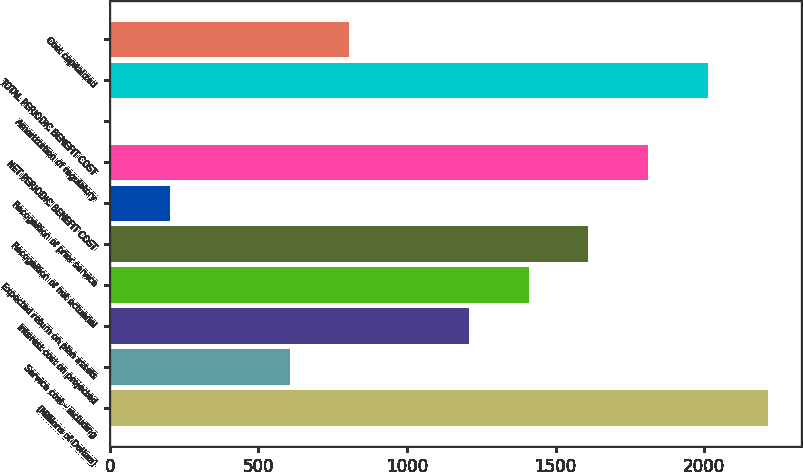<chart> <loc_0><loc_0><loc_500><loc_500><bar_chart><fcel>(Millions of Dollars)<fcel>Service cost - including<fcel>Interest cost on projected<fcel>Expected return on plan assets<fcel>Recognition of net actuarial<fcel>Recognition of prior service<fcel>NET PERIODIC BENEFIT COST<fcel>Amortization of regulatory<fcel>TOTAL PERIODIC BENEFIT COST<fcel>Cost capitalized<nl><fcel>2214.1<fcel>605.3<fcel>1208.6<fcel>1409.7<fcel>1610.8<fcel>203.1<fcel>1811.9<fcel>2<fcel>2013<fcel>806.4<nl></chart> 